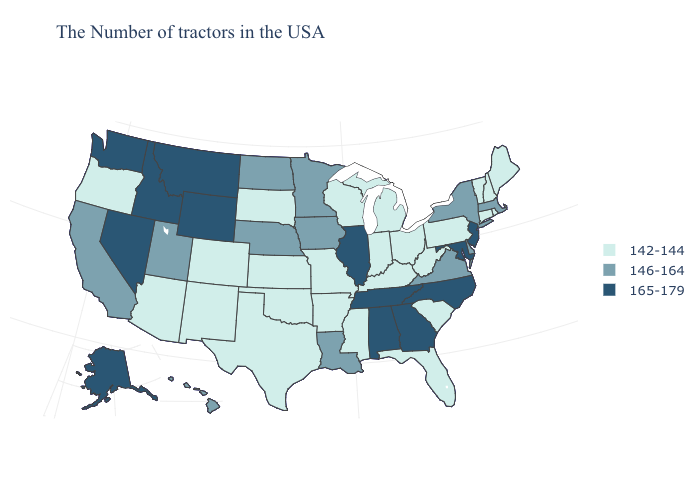Does New Hampshire have a lower value than Virginia?
Be succinct. Yes. What is the highest value in the Northeast ?
Answer briefly. 165-179. Name the states that have a value in the range 146-164?
Write a very short answer. Massachusetts, New York, Delaware, Virginia, Louisiana, Minnesota, Iowa, Nebraska, North Dakota, Utah, California, Hawaii. How many symbols are there in the legend?
Quick response, please. 3. Name the states that have a value in the range 146-164?
Short answer required. Massachusetts, New York, Delaware, Virginia, Louisiana, Minnesota, Iowa, Nebraska, North Dakota, Utah, California, Hawaii. Which states have the lowest value in the USA?
Keep it brief. Maine, Rhode Island, New Hampshire, Vermont, Connecticut, Pennsylvania, South Carolina, West Virginia, Ohio, Florida, Michigan, Kentucky, Indiana, Wisconsin, Mississippi, Missouri, Arkansas, Kansas, Oklahoma, Texas, South Dakota, Colorado, New Mexico, Arizona, Oregon. Name the states that have a value in the range 142-144?
Give a very brief answer. Maine, Rhode Island, New Hampshire, Vermont, Connecticut, Pennsylvania, South Carolina, West Virginia, Ohio, Florida, Michigan, Kentucky, Indiana, Wisconsin, Mississippi, Missouri, Arkansas, Kansas, Oklahoma, Texas, South Dakota, Colorado, New Mexico, Arizona, Oregon. Is the legend a continuous bar?
Give a very brief answer. No. Among the states that border Rhode Island , which have the lowest value?
Keep it brief. Connecticut. Among the states that border New York , which have the lowest value?
Short answer required. Vermont, Connecticut, Pennsylvania. What is the lowest value in the MidWest?
Write a very short answer. 142-144. What is the value of South Carolina?
Give a very brief answer. 142-144. What is the highest value in the South ?
Quick response, please. 165-179. Does Illinois have the highest value in the MidWest?
Answer briefly. Yes. What is the value of Nebraska?
Answer briefly. 146-164. 